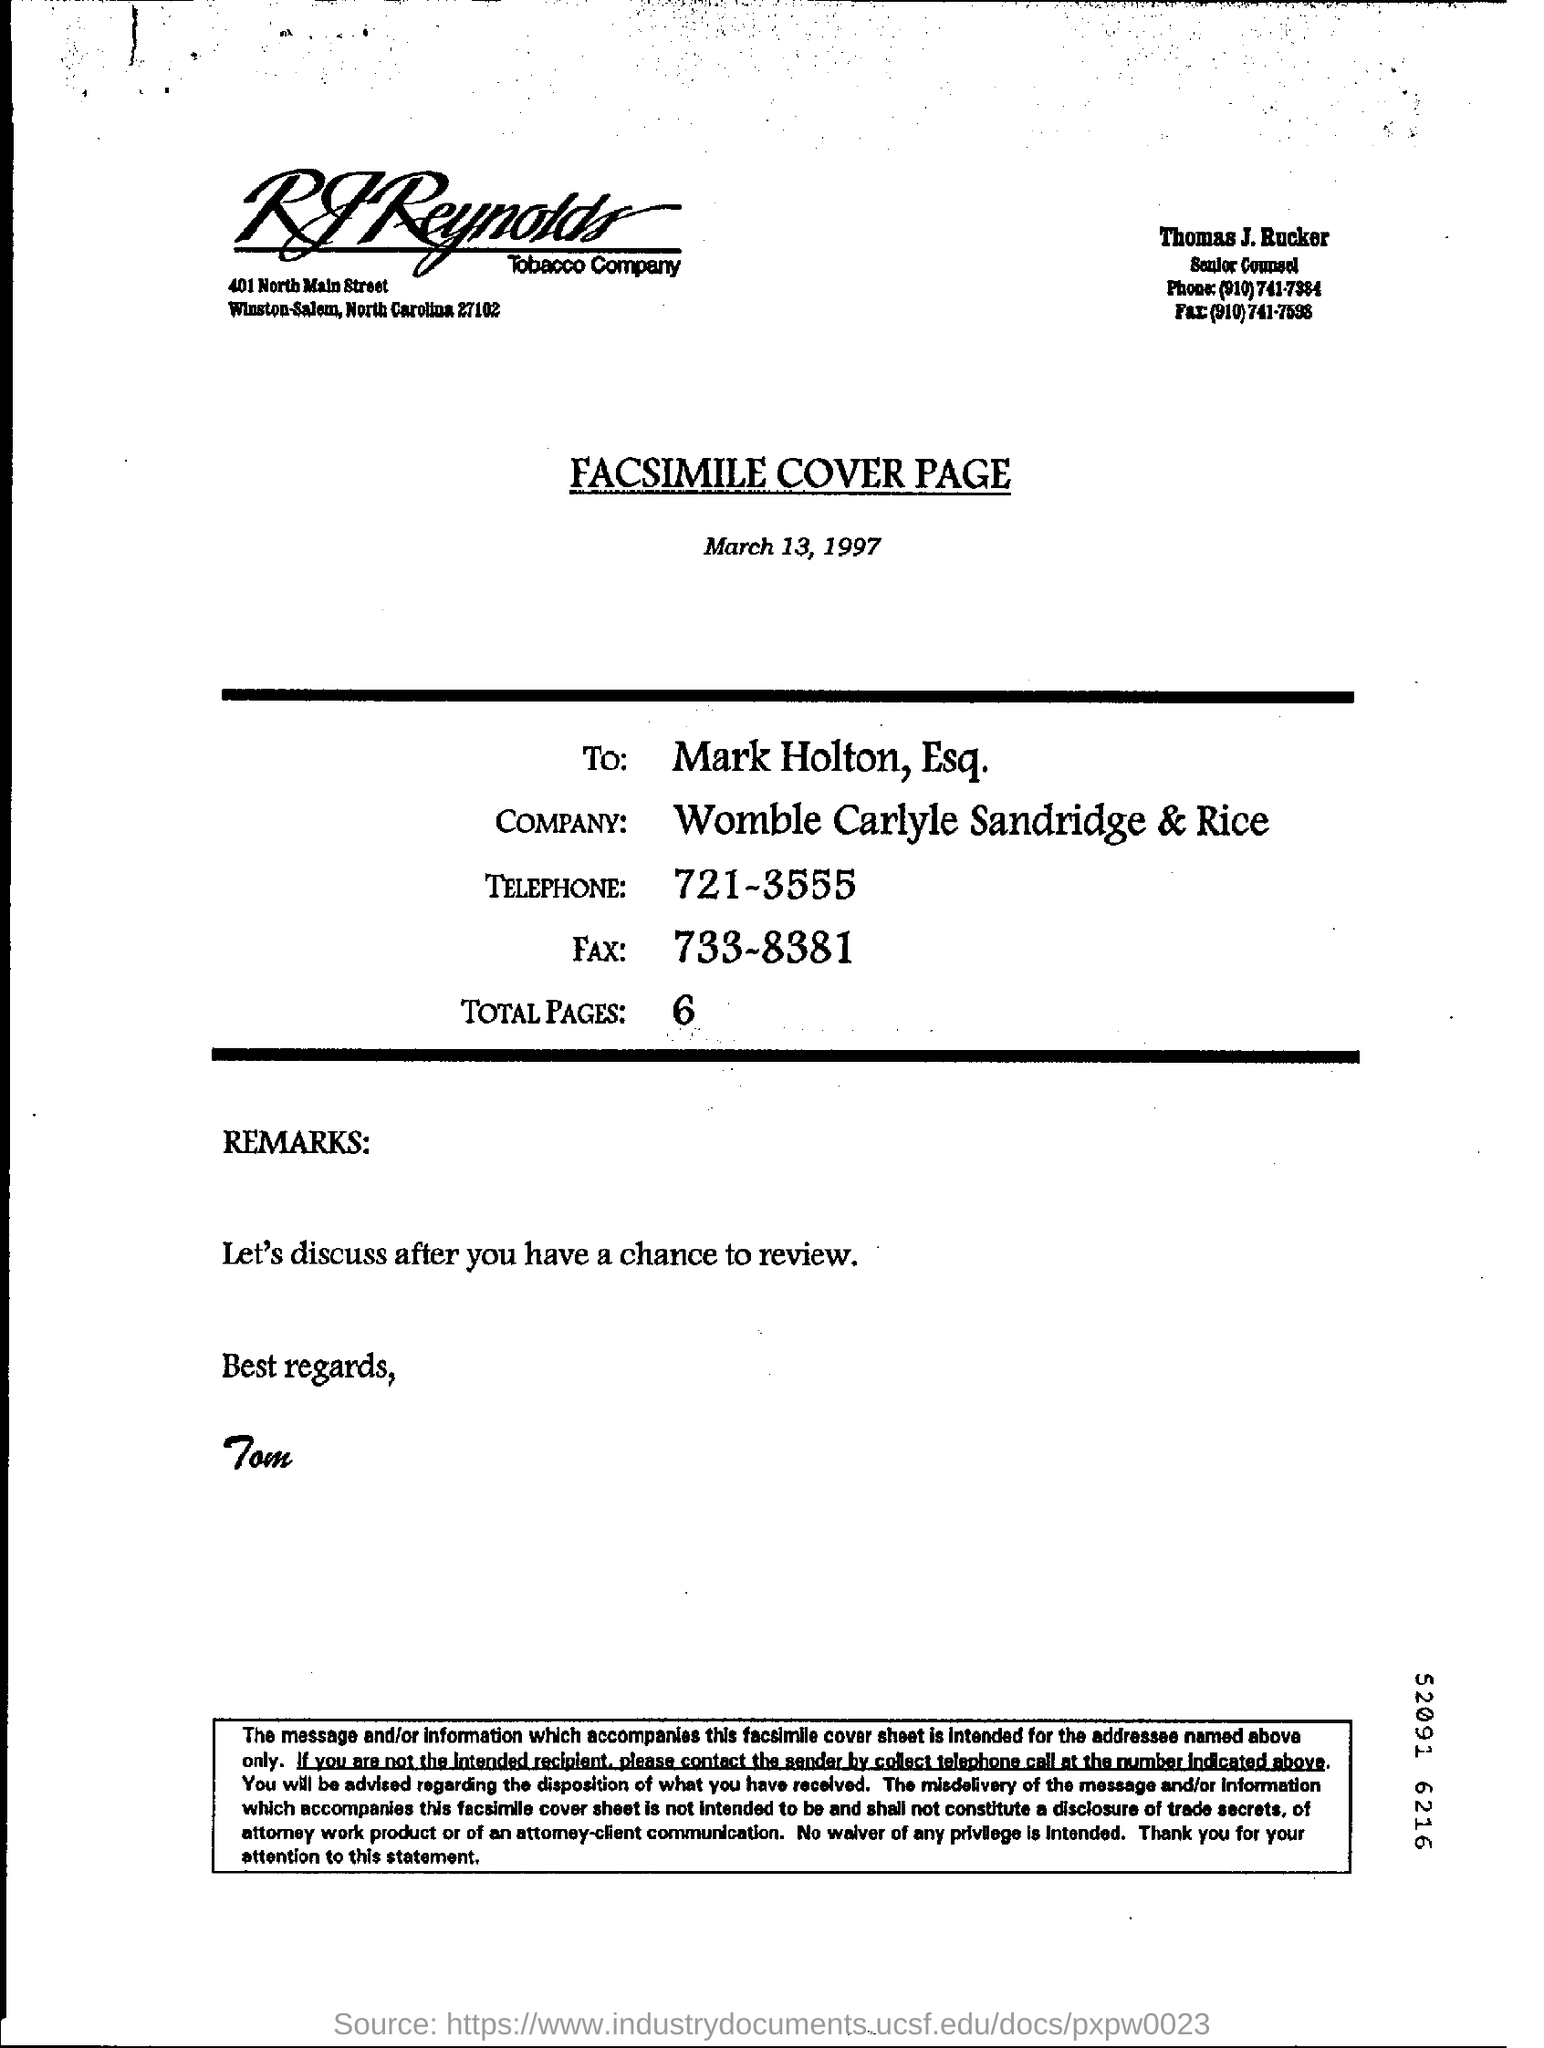Give some essential details in this illustration. The facsimile is addressed to Mark Holton, Esq. The person to whom best regards is wished is Tom. There are a total of 6 pages. 